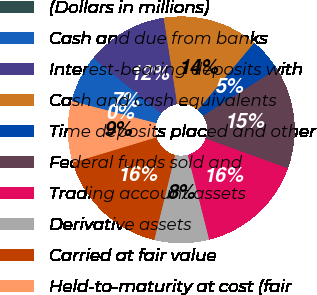<chart> <loc_0><loc_0><loc_500><loc_500><pie_chart><fcel>(Dollars in millions)<fcel>Cash and due from banks<fcel>Interest-bearing deposits with<fcel>Cash and cash equivalents<fcel>Time deposits placed and other<fcel>Federal funds sold and<fcel>Trading account assets<fcel>Derivative assets<fcel>Carried at fair value<fcel>Held-to-maturity at cost (fair<nl><fcel>0.01%<fcel>6.8%<fcel>11.65%<fcel>13.59%<fcel>4.86%<fcel>14.56%<fcel>15.53%<fcel>7.77%<fcel>16.5%<fcel>8.74%<nl></chart> 